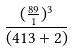<formula> <loc_0><loc_0><loc_500><loc_500>\frac { ( \frac { 8 9 } { 1 } ) ^ { 3 } } { ( 4 1 3 + 2 ) }</formula> 